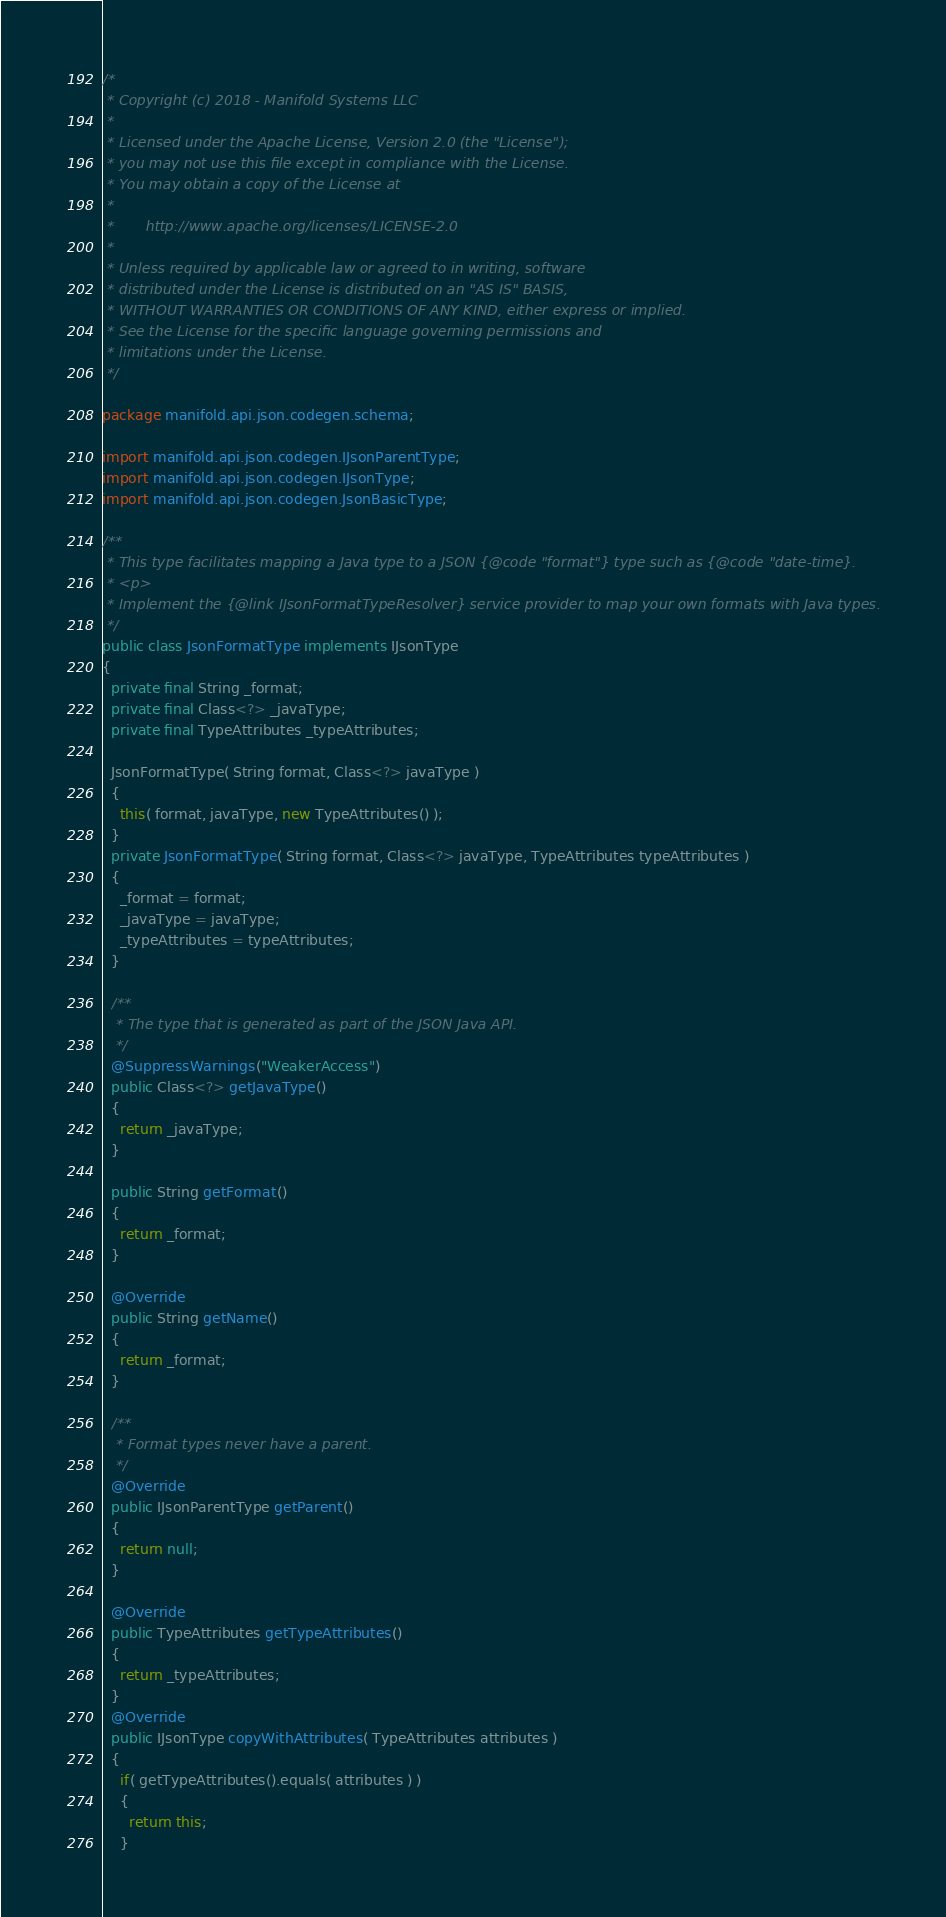<code> <loc_0><loc_0><loc_500><loc_500><_Java_>/*
 * Copyright (c) 2018 - Manifold Systems LLC
 *
 * Licensed under the Apache License, Version 2.0 (the "License");
 * you may not use this file except in compliance with the License.
 * You may obtain a copy of the License at
 *
 *       http://www.apache.org/licenses/LICENSE-2.0
 *
 * Unless required by applicable law or agreed to in writing, software
 * distributed under the License is distributed on an "AS IS" BASIS,
 * WITHOUT WARRANTIES OR CONDITIONS OF ANY KIND, either express or implied.
 * See the License for the specific language governing permissions and
 * limitations under the License.
 */

package manifold.api.json.codegen.schema;

import manifold.api.json.codegen.IJsonParentType;
import manifold.api.json.codegen.IJsonType;
import manifold.api.json.codegen.JsonBasicType;

/**
 * This type facilitates mapping a Java type to a JSON {@code "format"} type such as {@code "date-time}.
 * <p>
 * Implement the {@link IJsonFormatTypeResolver} service provider to map your own formats with Java types.
 */
public class JsonFormatType implements IJsonType
{
  private final String _format;
  private final Class<?> _javaType;
  private final TypeAttributes _typeAttributes;

  JsonFormatType( String format, Class<?> javaType )
  {
    this( format, javaType, new TypeAttributes() );
  }
  private JsonFormatType( String format, Class<?> javaType, TypeAttributes typeAttributes )
  {
    _format = format;
    _javaType = javaType;
    _typeAttributes = typeAttributes;
  }

  /**
   * The type that is generated as part of the JSON Java API.
   */
  @SuppressWarnings("WeakerAccess")
  public Class<?> getJavaType()
  {
    return _javaType;
  }

  public String getFormat()
  {
    return _format;
  }

  @Override
  public String getName()
  {
    return _format;
  }

  /**
   * Format types never have a parent.
   */
  @Override
  public IJsonParentType getParent()
  {
    return null;
  }

  @Override
  public TypeAttributes getTypeAttributes()
  {
    return _typeAttributes;
  }
  @Override
  public IJsonType copyWithAttributes( TypeAttributes attributes )
  {
    if( getTypeAttributes().equals( attributes ) )
    {
      return this;
    }</code> 